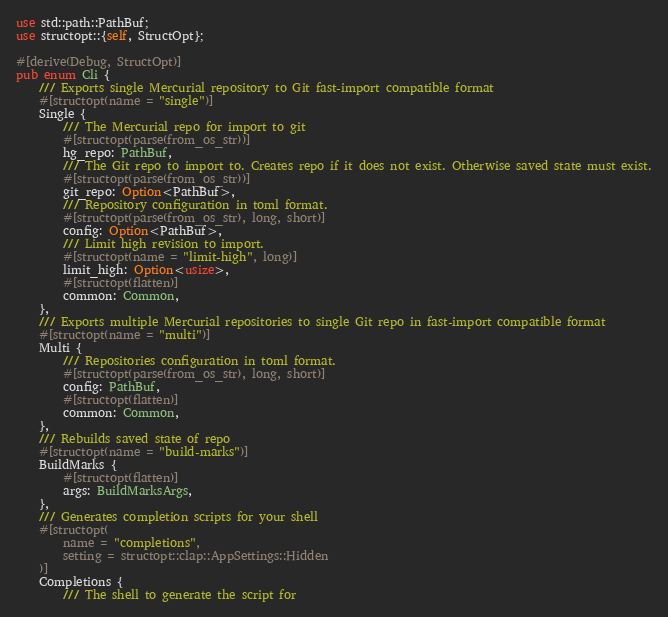<code> <loc_0><loc_0><loc_500><loc_500><_Rust_>use std::path::PathBuf;
use structopt::{self, StructOpt};

#[derive(Debug, StructOpt)]
pub enum Cli {
    /// Exports single Mercurial repository to Git fast-import compatible format
    #[structopt(name = "single")]
    Single {
        /// The Mercurial repo for import to git
        #[structopt(parse(from_os_str))]
        hg_repo: PathBuf,
        /// The Git repo to import to. Creates repo if it does not exist. Otherwise saved state must exist.
        #[structopt(parse(from_os_str))]
        git_repo: Option<PathBuf>,
        /// Repository configuration in toml format.
        #[structopt(parse(from_os_str), long, short)]
        config: Option<PathBuf>,
        /// Limit high revision to import.
        #[structopt(name = "limit-high", long)]
        limit_high: Option<usize>,
        #[structopt(flatten)]
        common: Common,
    },
    /// Exports multiple Mercurial repositories to single Git repo in fast-import compatible format
    #[structopt(name = "multi")]
    Multi {
        /// Repositories configuration in toml format.
        #[structopt(parse(from_os_str), long, short)]
        config: PathBuf,
        #[structopt(flatten)]
        common: Common,
    },
    /// Rebuilds saved state of repo
    #[structopt(name = "build-marks")]
    BuildMarks {
        #[structopt(flatten)]
        args: BuildMarksArgs,
    },
    /// Generates completion scripts for your shell
    #[structopt(
        name = "completions",
        setting = structopt::clap::AppSettings::Hidden
    )]
    Completions {
        /// The shell to generate the script for</code> 